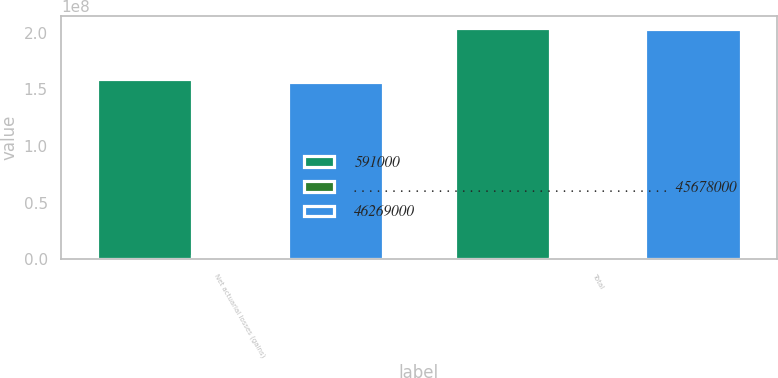Convert chart to OTSL. <chart><loc_0><loc_0><loc_500><loc_500><stacked_bar_chart><ecel><fcel>Net actuarial losses (gains)<fcel>Total<nl><fcel>591000<fcel>1.58906e+08<fcel>2.04584e+08<nl><fcel>. . . . . . . . . . . . . . . . . . . . . . . . . . . . . . . . . . . . . . . . .  45678000<fcel>2.741e+06<fcel>1.23e+06<nl><fcel>46269000<fcel>1.56165e+08<fcel>2.03354e+08<nl></chart> 